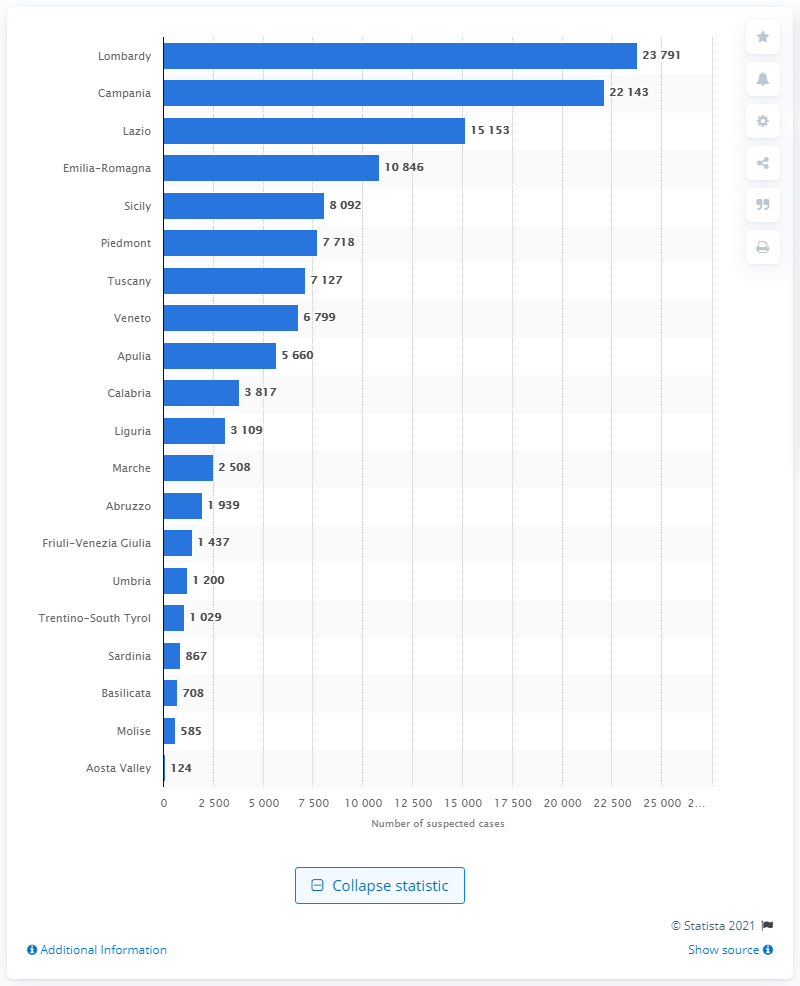Can you tell me which regions in Italy had fewer than 2,000 suspected financial operations in 2019? According to the data shown in the image, the regions in Italy with fewer than 2,000 suspected financial operations in 2019 were Abruzzo, Friuli-Venezia Giulia, Umbria, Trentino-South Tyrol, Sardinia, Basilicata, Molise, and Aosta Valley. 